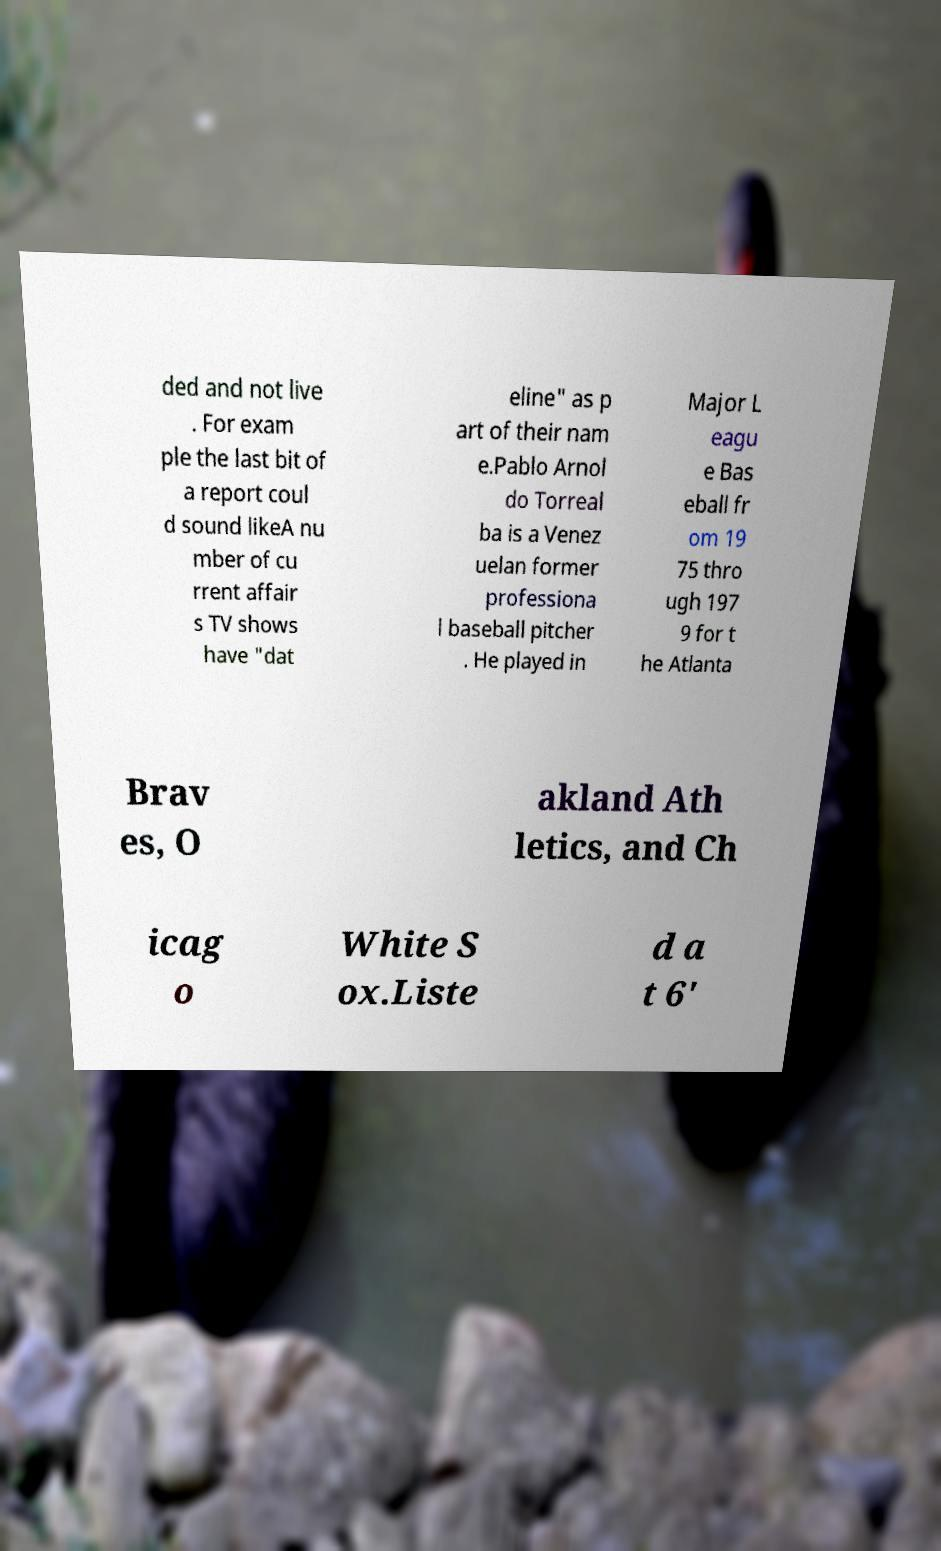Please identify and transcribe the text found in this image. ded and not live . For exam ple the last bit of a report coul d sound likeA nu mber of cu rrent affair s TV shows have "dat eline" as p art of their nam e.Pablo Arnol do Torreal ba is a Venez uelan former professiona l baseball pitcher . He played in Major L eagu e Bas eball fr om 19 75 thro ugh 197 9 for t he Atlanta Brav es, O akland Ath letics, and Ch icag o White S ox.Liste d a t 6' 